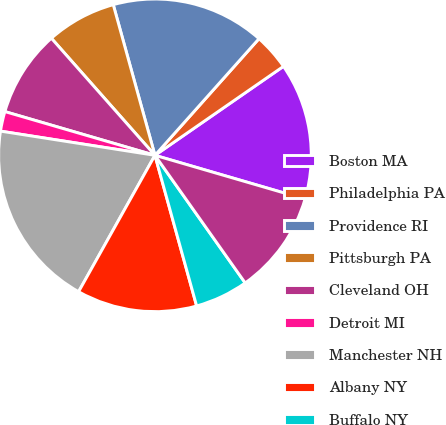<chart> <loc_0><loc_0><loc_500><loc_500><pie_chart><fcel>Boston MA<fcel>Philadelphia PA<fcel>Providence RI<fcel>Pittsburgh PA<fcel>Cleveland OH<fcel>Detroit MI<fcel>Manchester NH<fcel>Albany NY<fcel>Buffalo NY<fcel>Rochester NY<nl><fcel>14.15%<fcel>3.77%<fcel>15.89%<fcel>7.23%<fcel>8.96%<fcel>2.04%<fcel>19.35%<fcel>12.42%<fcel>5.5%<fcel>10.69%<nl></chart> 